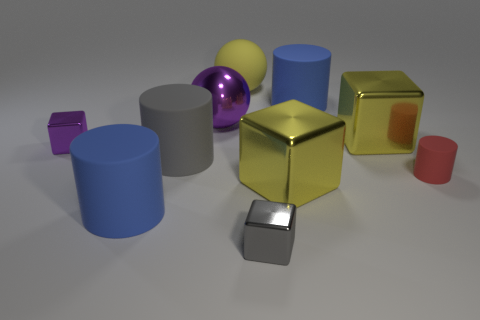How does the arrangement of these objects inform their perceived spatial relationships? The positioning of the objects in the image creates a sense of depth and hierarchy. Objects in the foreground, such as the small silver cube, demand immediate attention due to their proximity. In contrast, objects like the large blue cylinder in the back are perceived as being farther away, which is enhanced by the diminishing size and overlapping elements reinforcing the illusion of depth. 